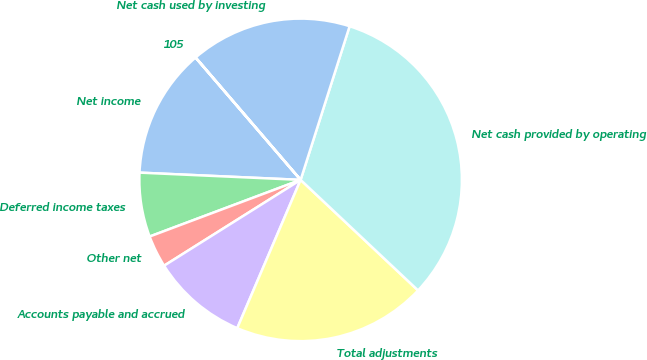<chart> <loc_0><loc_0><loc_500><loc_500><pie_chart><fcel>Net income<fcel>Deferred income taxes<fcel>Other net<fcel>Accounts payable and accrued<fcel>Total adjustments<fcel>Net cash provided by operating<fcel>Net cash used by investing<fcel>105<nl><fcel>12.99%<fcel>6.43%<fcel>3.22%<fcel>9.64%<fcel>19.41%<fcel>32.11%<fcel>16.2%<fcel>0.01%<nl></chart> 